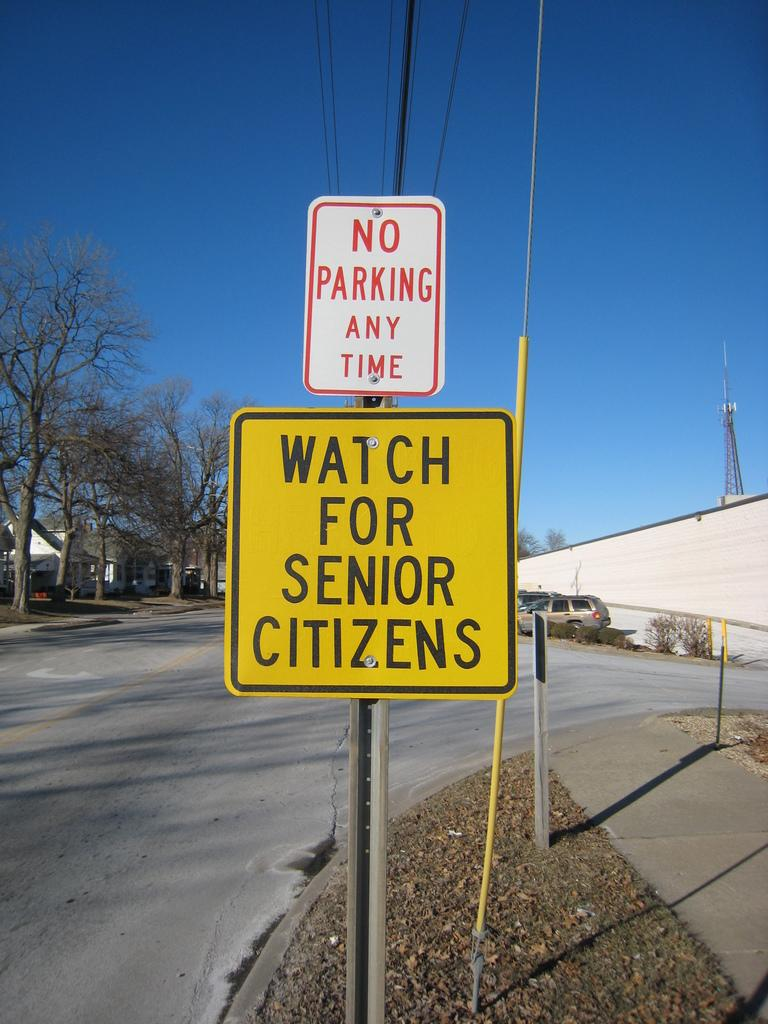<image>
Relay a brief, clear account of the picture shown. A No Parking Any Time sign above a yellow sign. 